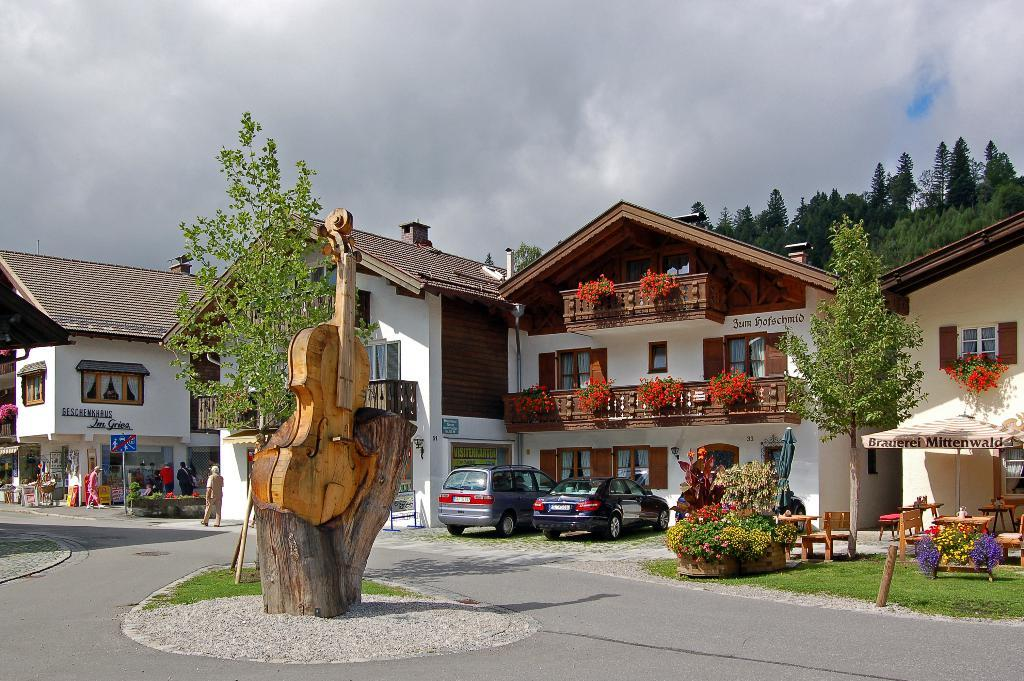What type of structures can be seen in the image? There are buildings in the image. What natural elements are present in the image? There are trees and plants in the image. What object can be seen that is typically used for making music? There is a guitar in the image. Are there any living beings visible in the image? Yes, there are people in the image. What part of the environment is visible in the image? The sky is visible in the image. What atmospheric conditions can be observed in the sky? Clouds are present in the sky. How many pets are visible in the image? There are no pets present in the image. What type of tail can be seen on the guitar in the image? There is no tail present on the guitar in the image; guitars do not have tails. 